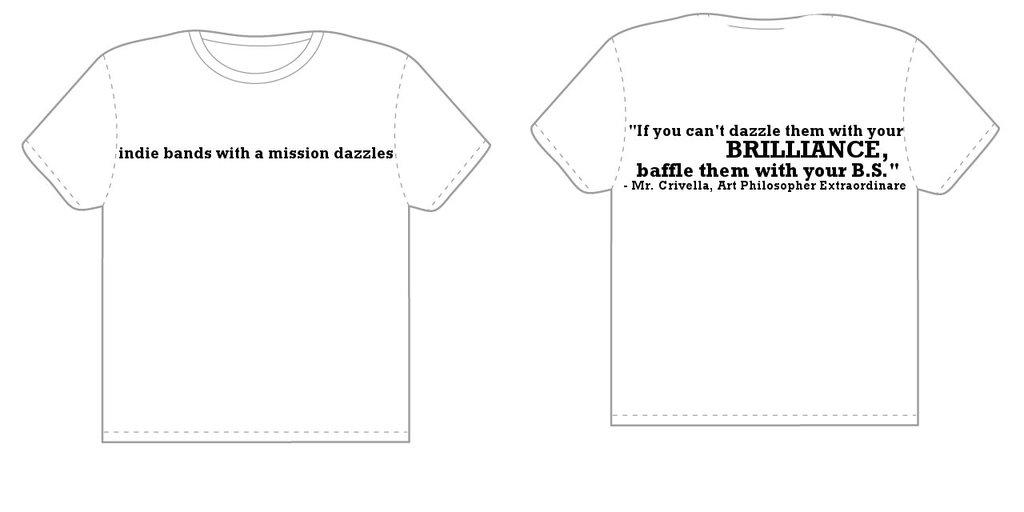<image>
Share a concise interpretation of the image provided. the word brilliance is on the white shirt 